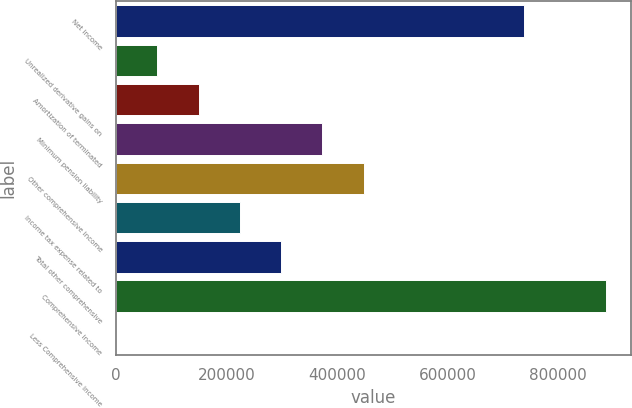Convert chart to OTSL. <chart><loc_0><loc_0><loc_500><loc_500><bar_chart><fcel>Net income<fcel>Unrealized derivative gains on<fcel>Amortization of terminated<fcel>Minimum pension liability<fcel>Other comprehensive income<fcel>Income tax expense related to<fcel>Total other comprehensive<fcel>Comprehensive income<fcel>Less Comprehensive income<nl><fcel>738024<fcel>74702.8<fcel>149404<fcel>373506<fcel>448207<fcel>224105<fcel>298806<fcel>887426<fcel>1.83<nl></chart> 